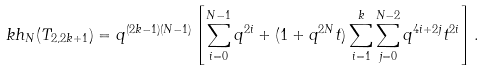<formula> <loc_0><loc_0><loc_500><loc_500>\ k h _ { N } ( T _ { 2 , 2 k + 1 } ) = q ^ { ( 2 k - 1 ) ( N - 1 ) } \left [ \sum _ { i = 0 } ^ { N - 1 } q ^ { 2 i } + ( 1 + q ^ { 2 N } t ) \sum _ { i = 1 } ^ { k } \sum _ { j = 0 } ^ { N - 2 } q ^ { 4 i + 2 j } t ^ { 2 i } \right ] .</formula> 